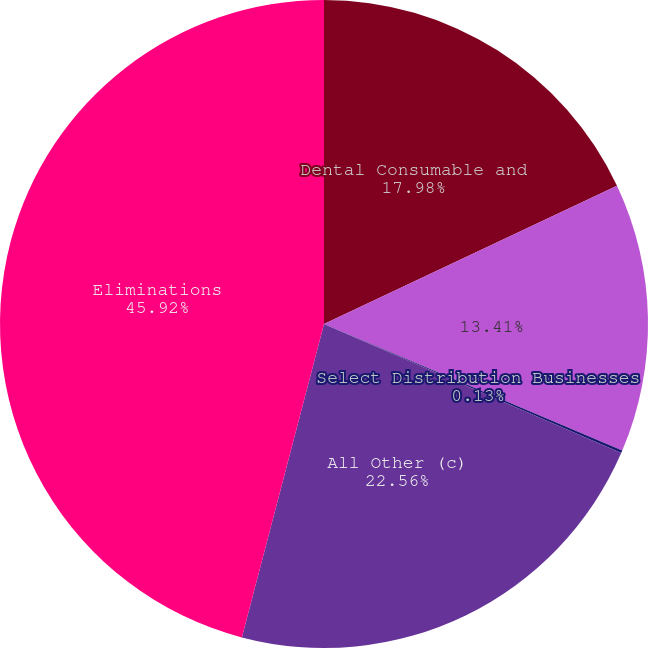<chart> <loc_0><loc_0><loc_500><loc_500><pie_chart><fcel>Dental Consumable and<fcel>Unnamed: 1<fcel>Select Distribution Businesses<fcel>All Other (c)<fcel>Eliminations<nl><fcel>17.98%<fcel>13.41%<fcel>0.13%<fcel>22.56%<fcel>45.92%<nl></chart> 